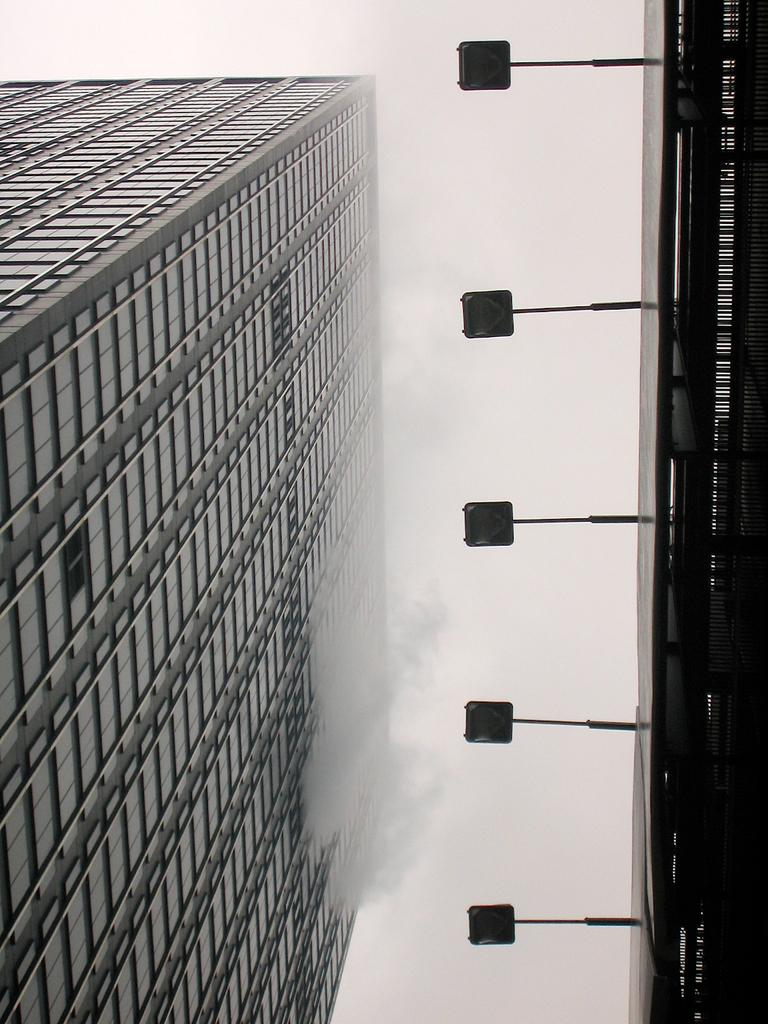What type of structures can be seen in the image? There are buildings in the image. What else can be seen in the image besides the buildings? There are lights visible in the image. What part of the natural environment is visible in the image? The sky is visible in the image. Can you see any cobwebs in the image? There is no mention of cobwebs in the image, so we cannot determine if any are present. 